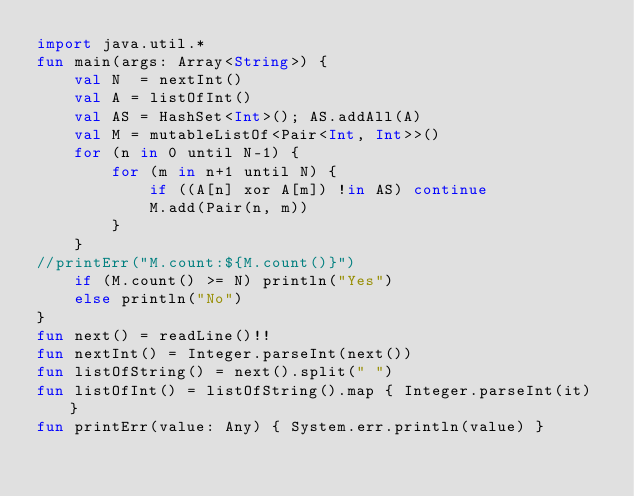<code> <loc_0><loc_0><loc_500><loc_500><_Kotlin_>import java.util.*
fun main(args: Array<String>) {
    val N  = nextInt()
    val A = listOfInt()
    val AS = HashSet<Int>(); AS.addAll(A)
    val M = mutableListOf<Pair<Int, Int>>()
    for (n in 0 until N-1) {
        for (m in n+1 until N) {
            if ((A[n] xor A[m]) !in AS) continue
            M.add(Pair(n, m))
        }
    }
//printErr("M.count:${M.count()}")
    if (M.count() >= N) println("Yes")
    else println("No")
}
fun next() = readLine()!!
fun nextInt() = Integer.parseInt(next())
fun listOfString() = next().split(" ")
fun listOfInt() = listOfString().map { Integer.parseInt(it) }
fun printErr(value: Any) { System.err.println(value) }
</code> 